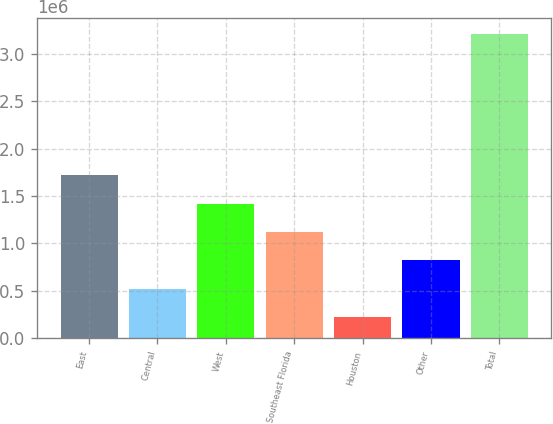Convert chart. <chart><loc_0><loc_0><loc_500><loc_500><bar_chart><fcel>East<fcel>Central<fcel>West<fcel>Southeast Florida<fcel>Houston<fcel>Other<fcel>Total<nl><fcel>1.71747e+06<fcel>521606<fcel>1.4185e+06<fcel>1.11954e+06<fcel>222641<fcel>820571<fcel>3.21229e+06<nl></chart> 